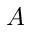<formula> <loc_0><loc_0><loc_500><loc_500>A</formula> 